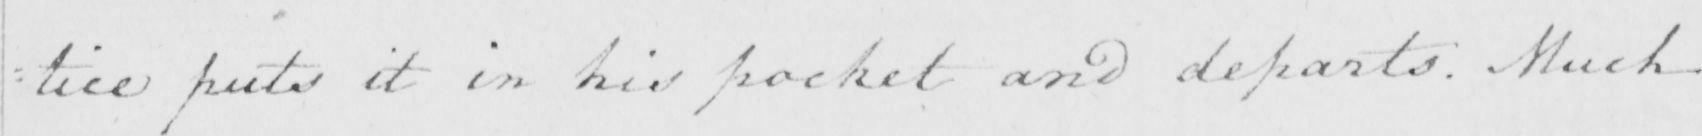What text is written in this handwritten line? : tice puts it in his pocket and departs . Much 